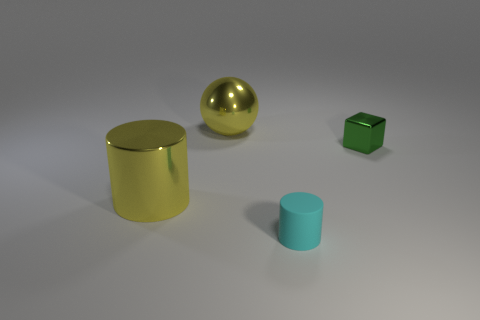How many matte objects are big blue things or tiny cyan objects?
Provide a short and direct response. 1. There is a shiny object that is the same color as the large cylinder; what shape is it?
Give a very brief answer. Sphere. There is a big shiny thing that is behind the yellow cylinder; does it have the same color as the tiny matte object?
Your answer should be compact. No. The big yellow object that is in front of the big yellow object that is behind the large cylinder is what shape?
Offer a terse response. Cylinder. How many objects are either large yellow objects on the right side of the large cylinder or yellow metallic objects that are on the left side of the yellow metallic sphere?
Ensure brevity in your answer.  2. There is a small green object that is made of the same material as the sphere; what is its shape?
Offer a terse response. Cube. Is there any other thing that has the same color as the cube?
Make the answer very short. No. There is a big yellow object that is the same shape as the tiny matte thing; what material is it?
Offer a very short reply. Metal. What number of other things are there of the same size as the matte object?
Give a very brief answer. 1. What material is the green block?
Provide a succinct answer. Metal. 